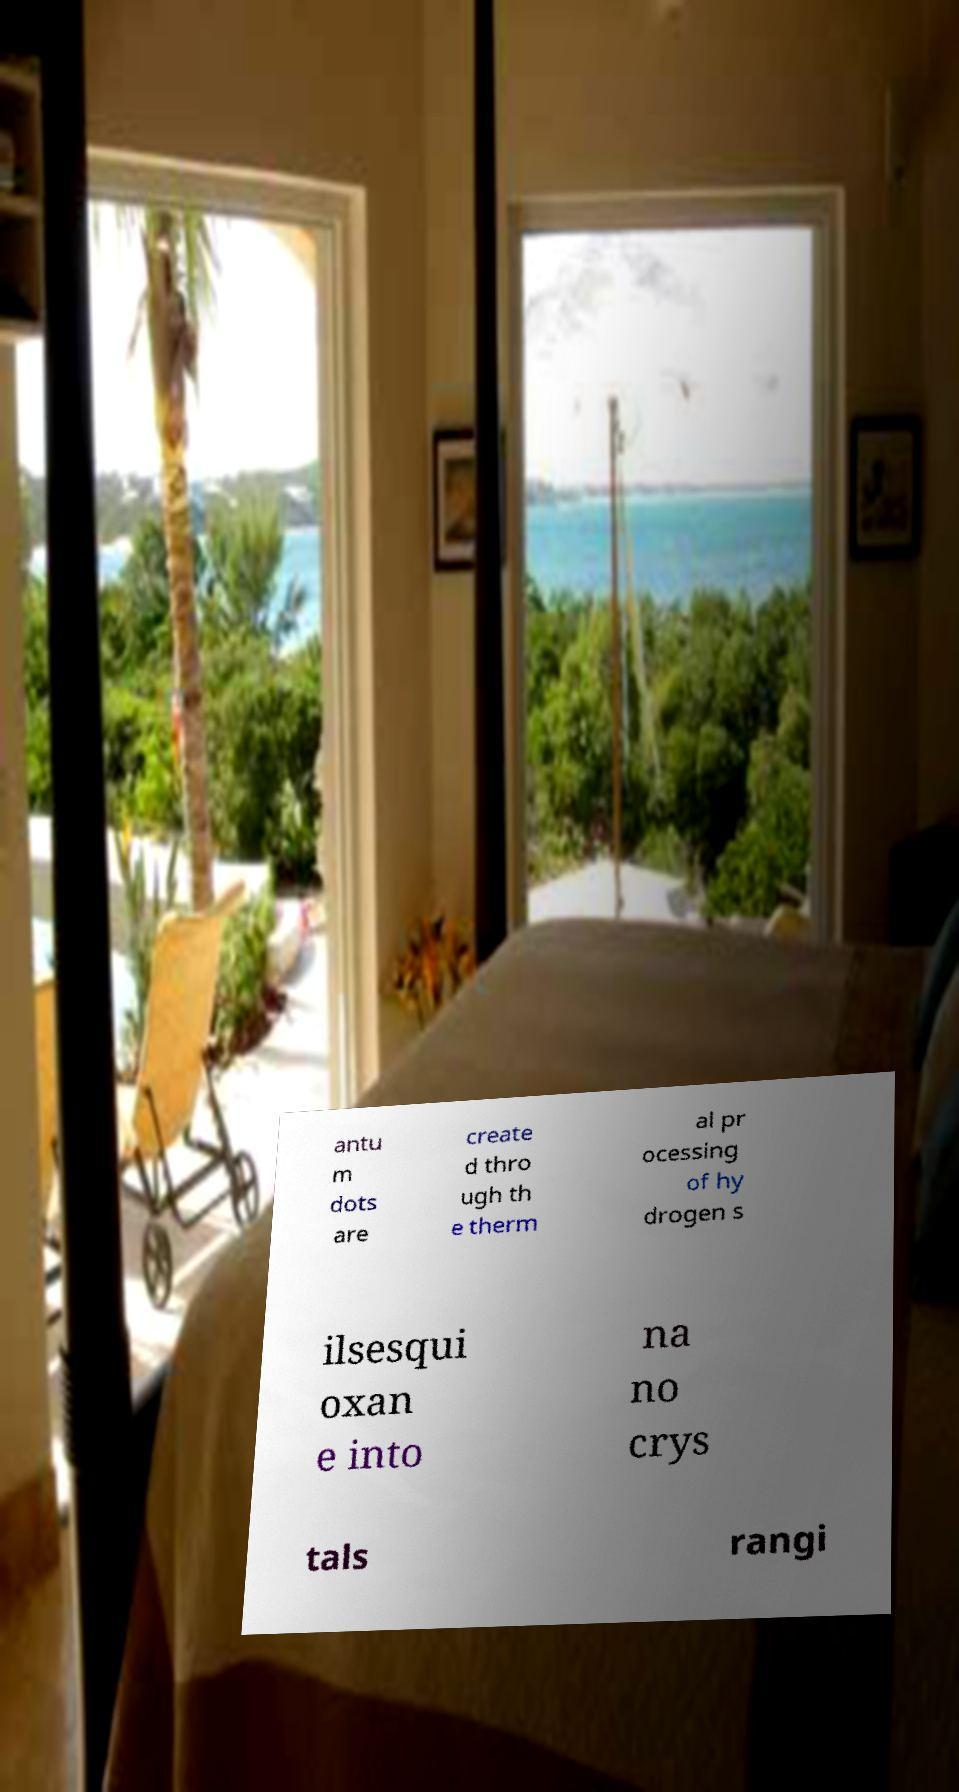Could you assist in decoding the text presented in this image and type it out clearly? antu m dots are create d thro ugh th e therm al pr ocessing of hy drogen s ilsesqui oxan e into na no crys tals rangi 